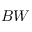Convert formula to latex. <formula><loc_0><loc_0><loc_500><loc_500>B W</formula> 